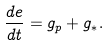Convert formula to latex. <formula><loc_0><loc_0><loc_500><loc_500>\frac { d e } { d t } = g _ { p } + g _ { \ast } .</formula> 